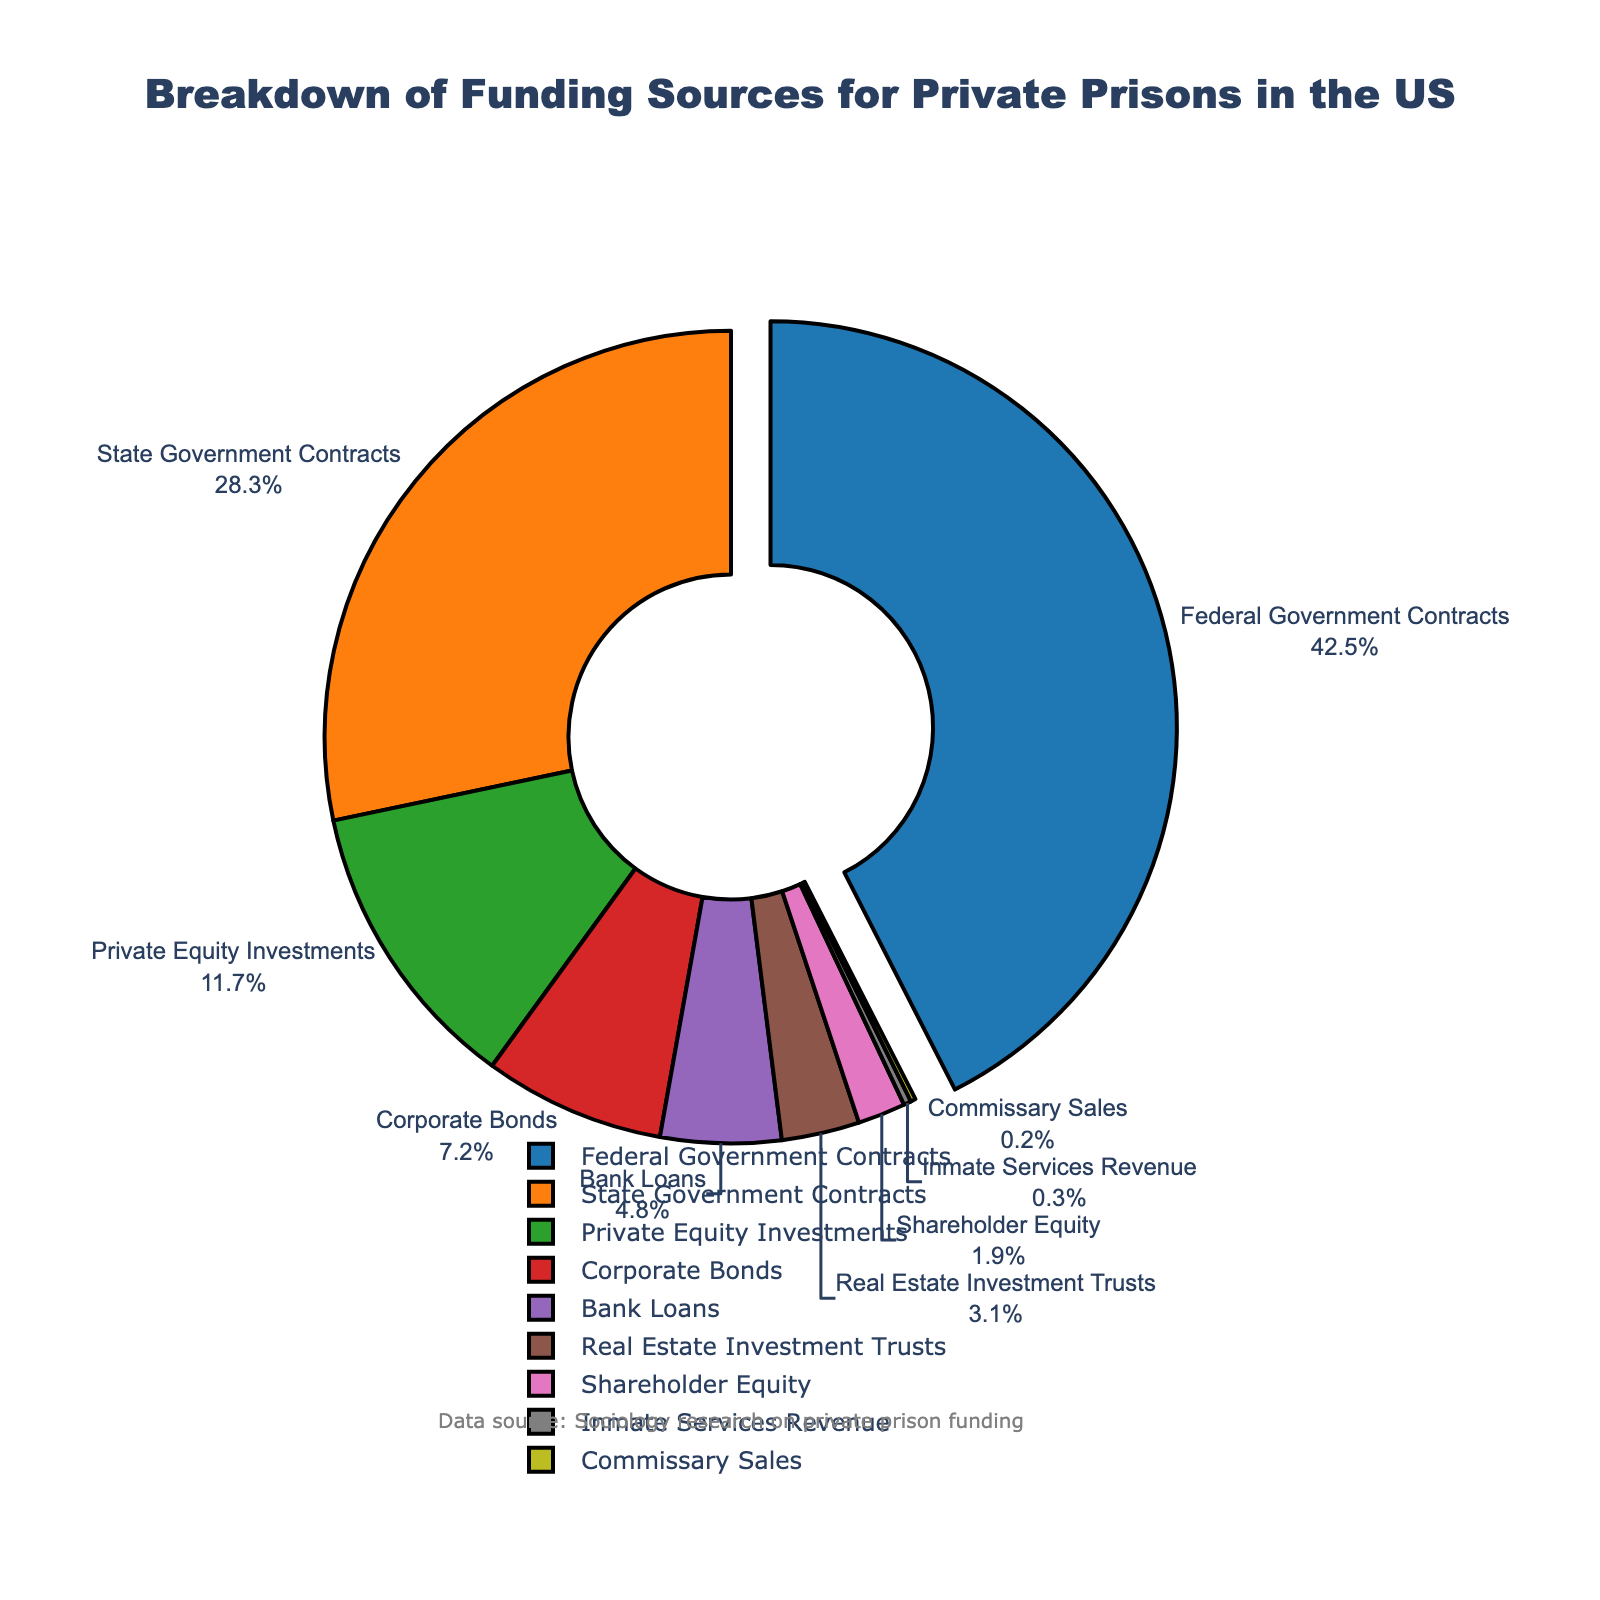What is the largest source of funding for private prisons? The largest portion is visually distinct because it is pulled out from the pie chart. It is labeled as "Federal Government Contracts" with a percentage clearly marked.
Answer: Federal Government Contracts What is the combined percentage of funding from State Government Contracts and Private Equity Investments? To find this combined percentage, sum the values for State Government Contracts (28.3%) and Private Equity Investments (11.7%). 28.3 + 11.7 = 40.0%
Answer: 40.0% Which two funding sources have the lowest contributions, and what are their percentages? Identify the smallest slices in the pie chart, which are labeled Inmate Services Revenue (0.3%) and Commissary Sales (0.2%).
Answer: Inmate Services Revenue (0.3%) and Commissary Sales (0.2%) How does the funding percentage from Bank Loans compare to that from Corporate Bonds? The pie chart shows Bank Loans at 4.8% and Corporate Bonds at 7.2%. Compare these two percentages to see that Corporate Bonds have a higher percentage.
Answer: Corporate Bonds have a higher percentage Are the contributions from Private Equity Investments and Corporate Bonds together more or less than the Federal Government Contracts? Sum the percentages for Private Equity Investments (11.7%) and Corporate Bonds (7.2%), which is 11.7 + 7.2 = 18.9%. Compare this to the Federal Government Contracts percentage of 42.5%.
Answer: Less What percentage of funding comes from shareholder equity? Locate the slice labeled "Shareholder Equity" in the pie chart, which is marked at 1.9%.
Answer: 1.9% If the contributions from Bank Loans and Real Estate Investment Trusts are combined, would they surpass the contribution from State Government Contracts? Add the percentages for Bank Loans (4.8%) and Real Estate Investment Trusts (3.1%), which results in 4.8 + 3.1 = 7.9%. Compare this to 28.3% from State Government Contracts.
Answer: No Which funding source's slice stands out visually in the pie chart, and why? The slice labeled "Federal Government Contracts" is visually distinct because it is slightly pulled out from the pie chart, drawing attention to its higher percentage.
Answer: Federal Government Contracts What is the total percentage of funding from Bank Loans, Real Estate Investment Trusts, and Shareholder Equity combined? Sum the percentages for Bank Loans (4.8%), Real Estate Investment Trusts (3.1%), and Shareholder Equity (1.9%). 4.8 + 3.1 + 1.9 = 9.8%
Answer: 9.8% 